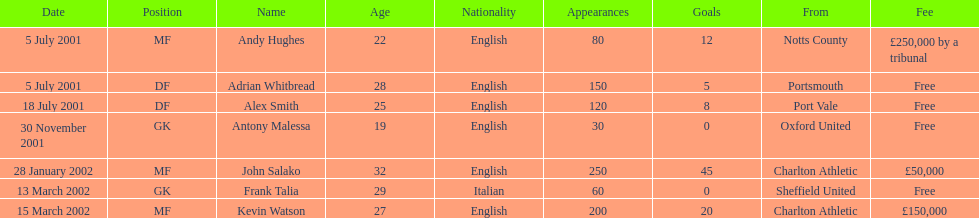What is the total number of free fees? 4. 